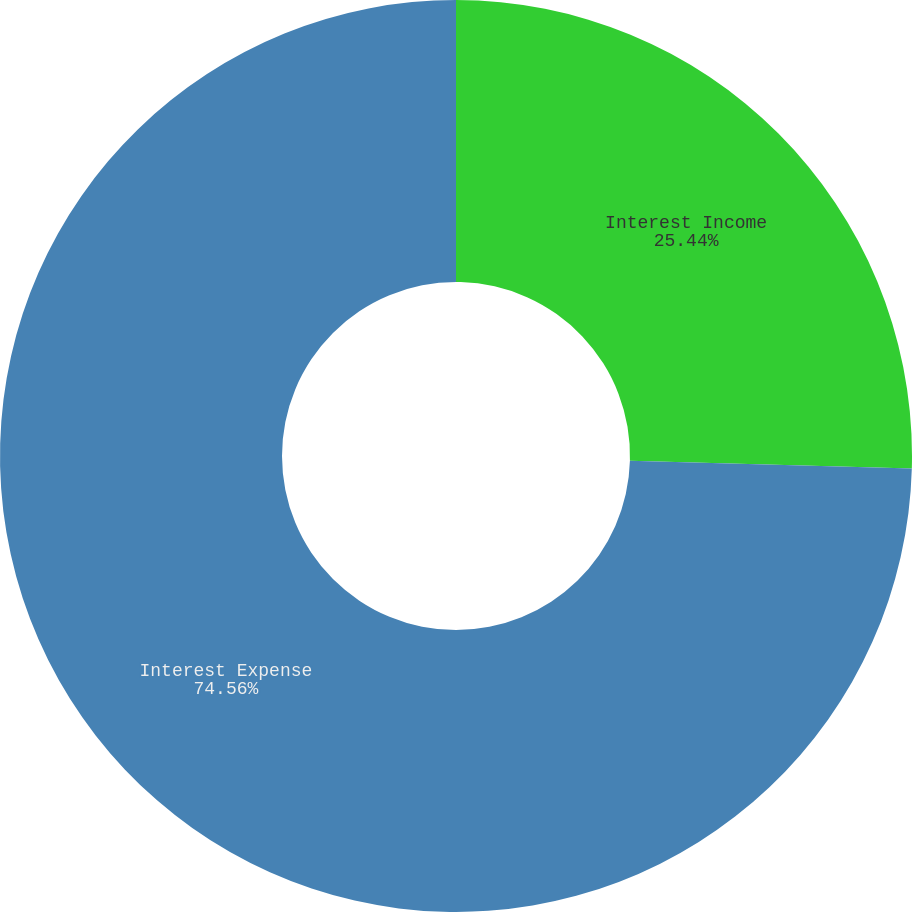<chart> <loc_0><loc_0><loc_500><loc_500><pie_chart><fcel>Interest Income<fcel>Interest Expense<nl><fcel>25.44%<fcel>74.56%<nl></chart> 